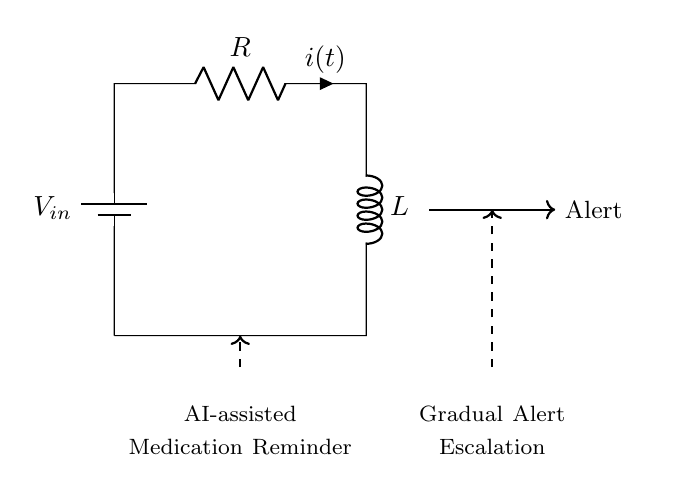What are the components in this circuit? The circuit includes a battery, a resistor, and an inductor. These components are connected in a closed loop to form the RL circuit.
Answer: Battery, resistor, inductor What is the symbol for the current in this circuit? The current is denoted by "i" and is represented as flowing through the resistor in the circuit diagram.
Answer: i What is the function of the battery in this circuit? The battery provides the input voltage needed to drive current through the circuit, which is essential for the operation of the resistor and inductor.
Answer: Input voltage What type of circuit is depicted here? This is a resistor-inductor circuit, commonly referred to as an RL circuit, characterized by the presence of both a resistor and an inductor connected in series.
Answer: RL circuit How does the current behave in an RL circuit over time? In an RL circuit, the current increases gradually over time when the circuit is powered, as it is opposed by the inductance, leading to a time-delay effect. This behavior is a key characteristic of RL circuits.
Answer: Gradual increase What does the arrow indicating "Alert" represent? The arrow labeled "Alert" signifies that the circuit is connected to an AI-assisted medication reminder device that escalates alerts based on the state of the circuit, potentially related to the current flow.
Answer: Alert system Why is the relationship between resistance and inductance important in this circuit? The resistance affects the time constant of the circuit, which determines how quickly the current will rise to its maximum value when the circuit is activated. This relationship is crucial for ensuring that the medication reminders escalate appropriately over time.
Answer: Time constant 